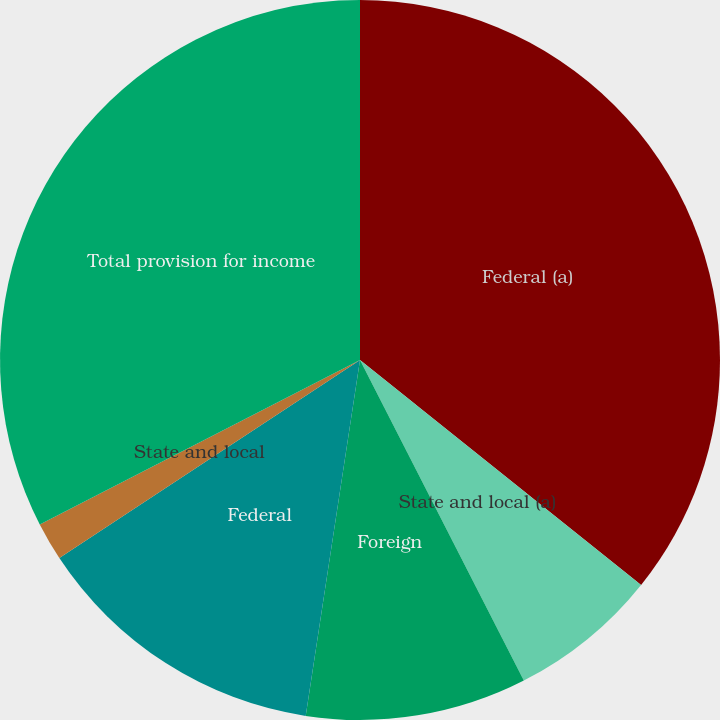Convert chart. <chart><loc_0><loc_0><loc_500><loc_500><pie_chart><fcel>Federal (a)<fcel>State and local (a)<fcel>Foreign<fcel>Federal<fcel>State and local<fcel>Total provision for income<nl><fcel>35.74%<fcel>6.74%<fcel>9.93%<fcel>13.32%<fcel>1.72%<fcel>32.55%<nl></chart> 